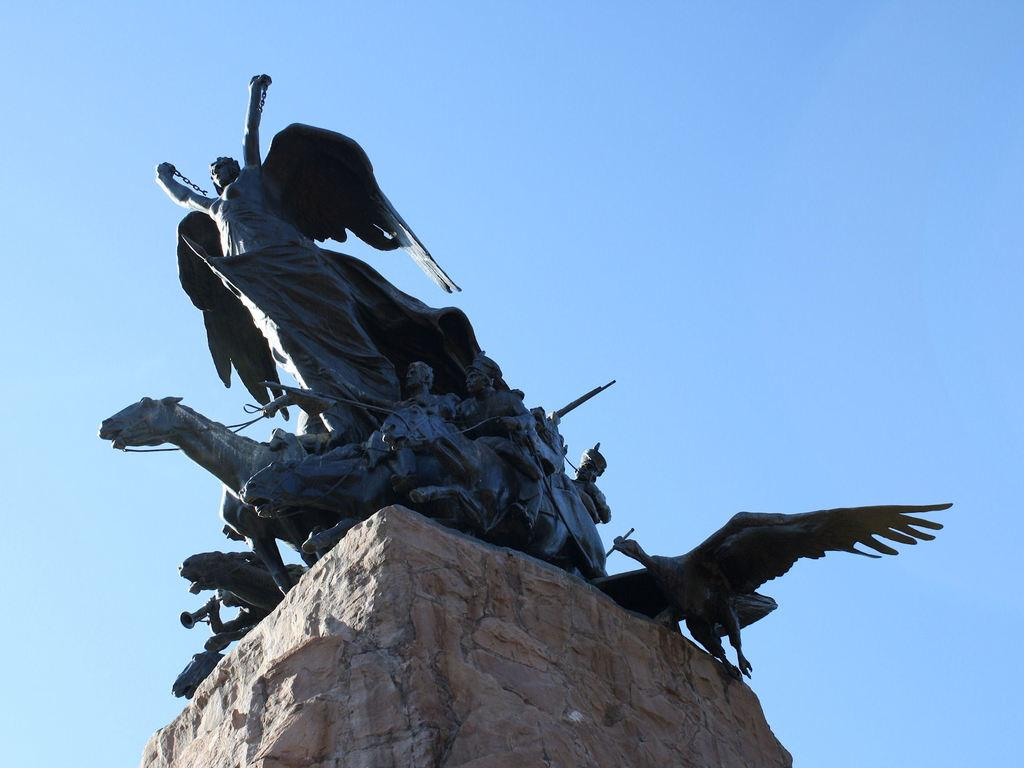What is the main subject of the image? There is a statue in the image. What does the statue depict? The statue depicts multiple persons and animals. What is the color of the statue? The statue is black in color. Where is the statue located? The statue is on a rock. What is the color of the rock? The rock is brown in color. What can be seen in the background of the image? The sky is visible in the background of the image. How many dolls are sitting on the edge of the statue in the image? There are no dolls present in the image, and the statue does not have an edge for dolls to sit on. 